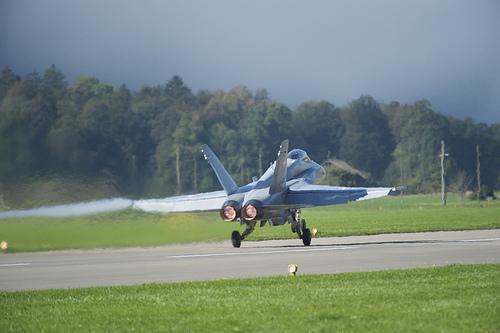How many planes are there?
Give a very brief answer. 1. 